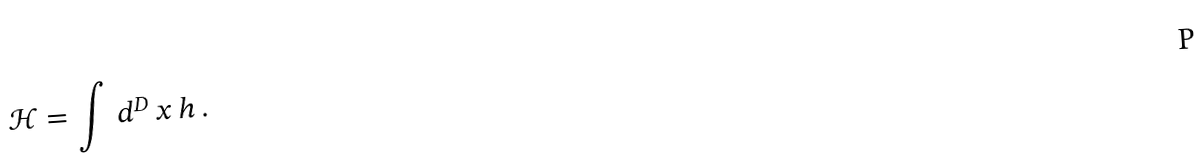Convert formula to latex. <formula><loc_0><loc_0><loc_500><loc_500>\mathcal { H } = \int \, d ^ { D } \, x \, h \, .</formula> 